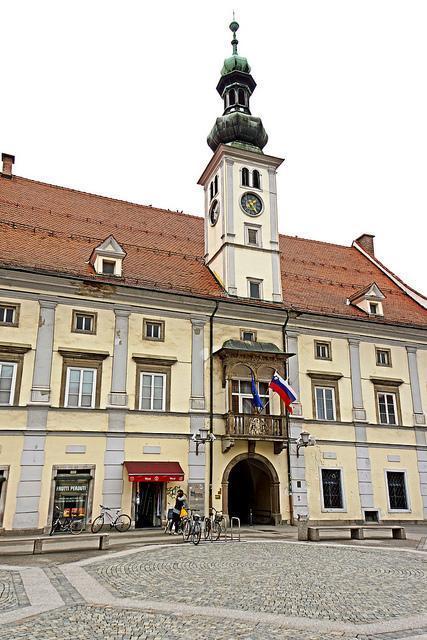How many flags are by the building's entrance?
Give a very brief answer. 2. How many zebras are in the photo?
Give a very brief answer. 0. 